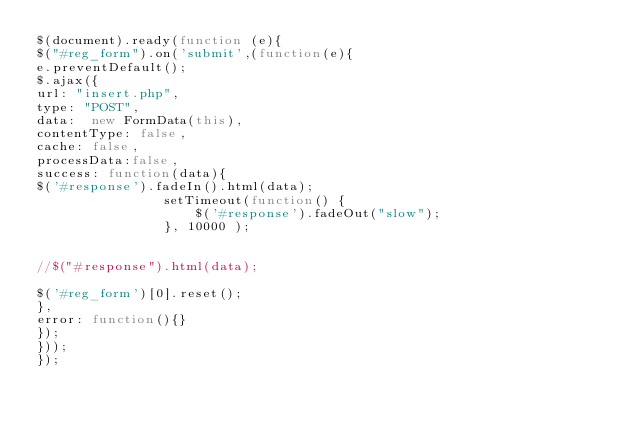<code> <loc_0><loc_0><loc_500><loc_500><_JavaScript_>$(document).ready(function (e){
$("#reg_form").on('submit',(function(e){
e.preventDefault();
$.ajax({
url: "insert.php",
type: "POST",
data:  new FormData(this),
contentType: false,
cache: false,
processData:false,
success: function(data){
$('#response').fadeIn().html(data);
				setTimeout(function() {
					$('#response').fadeOut("slow");
				}, 10000 );


//$("#response").html(data);

$('#reg_form')[0].reset();
},
error: function(){}             
});
}));
});

</code> 